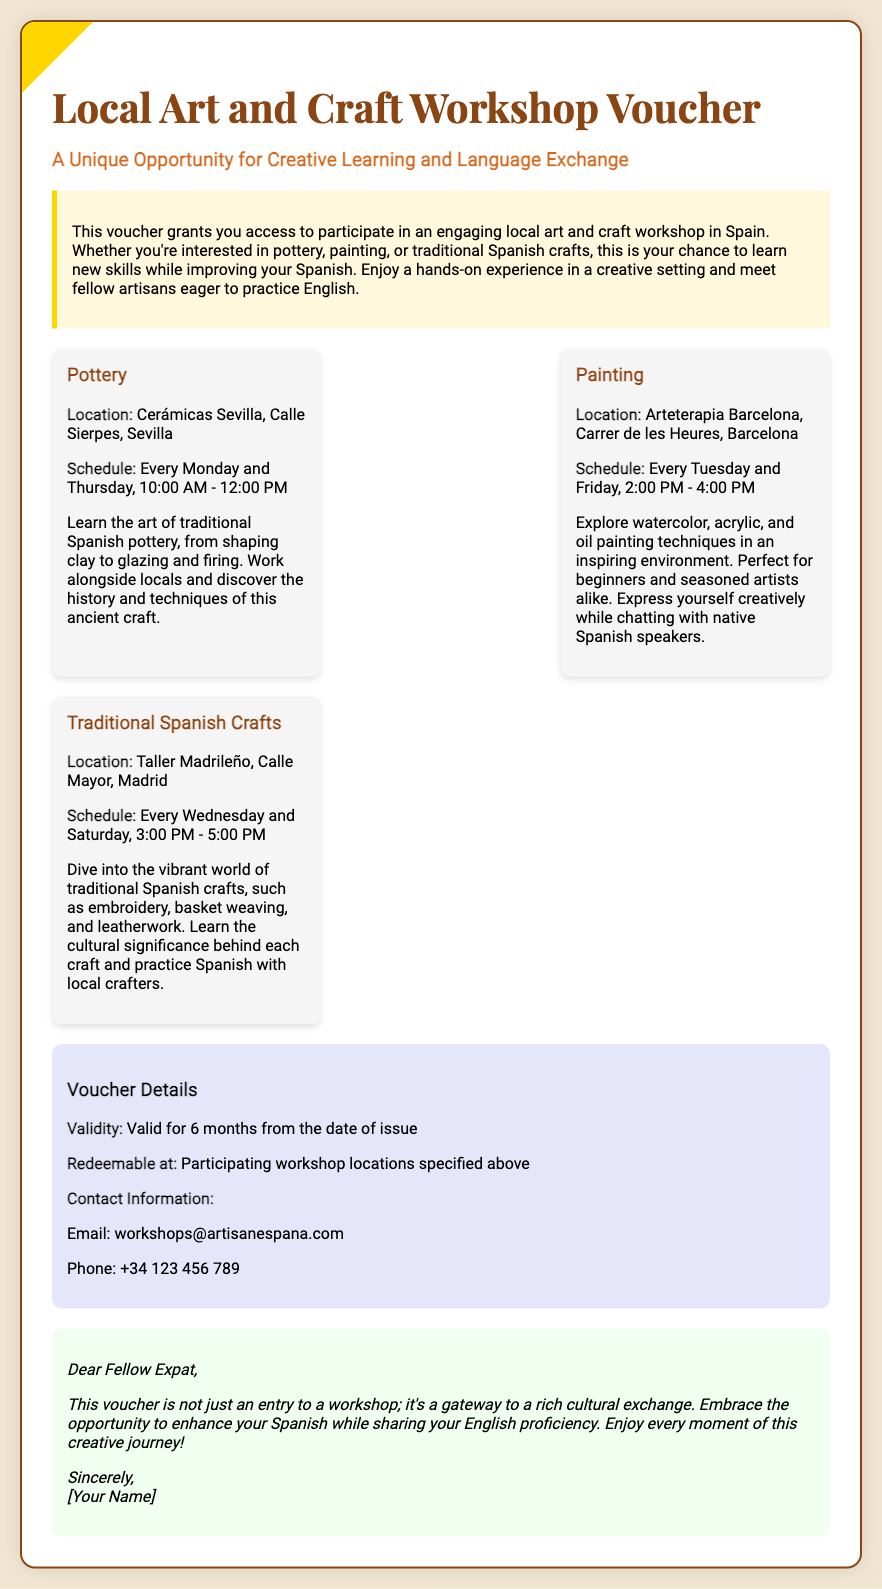What is the title of the voucher? The title of the voucher is mentioned prominently at the top of the document.
Answer: Local Art and Craft Workshop Voucher What types of workshops are offered? The document lists three specific types of workshops available for participants.
Answer: Pottery, Painting, Traditional Spanish Crafts What is the location for the Pottery workshop? The location of the Pottery workshop is provided in the description of that workshop.
Answer: Cerámicas Sevilla, Calle Sierpes, Sevilla On which days is the Painting workshop scheduled? The schedule for the Painting workshop specifies the days of the week it occurs.
Answer: Tuesday and Friday What is the validity period of the voucher? The document states how long the voucher is valid from the date it is issued.
Answer: 6 months Where can you contact for more information? The contact information is provided in the details section of the voucher.
Answer: workshops@artisanespana.com What is the purpose of this voucher? The document describes the main benefit that participants will gain from using the voucher.
Answer: Creative learning and language exchange What should participants expect during the workshops? The descriptions of each workshop explain the expected experiences for participants.
Answer: Hands-on experience and practicing Spanish 